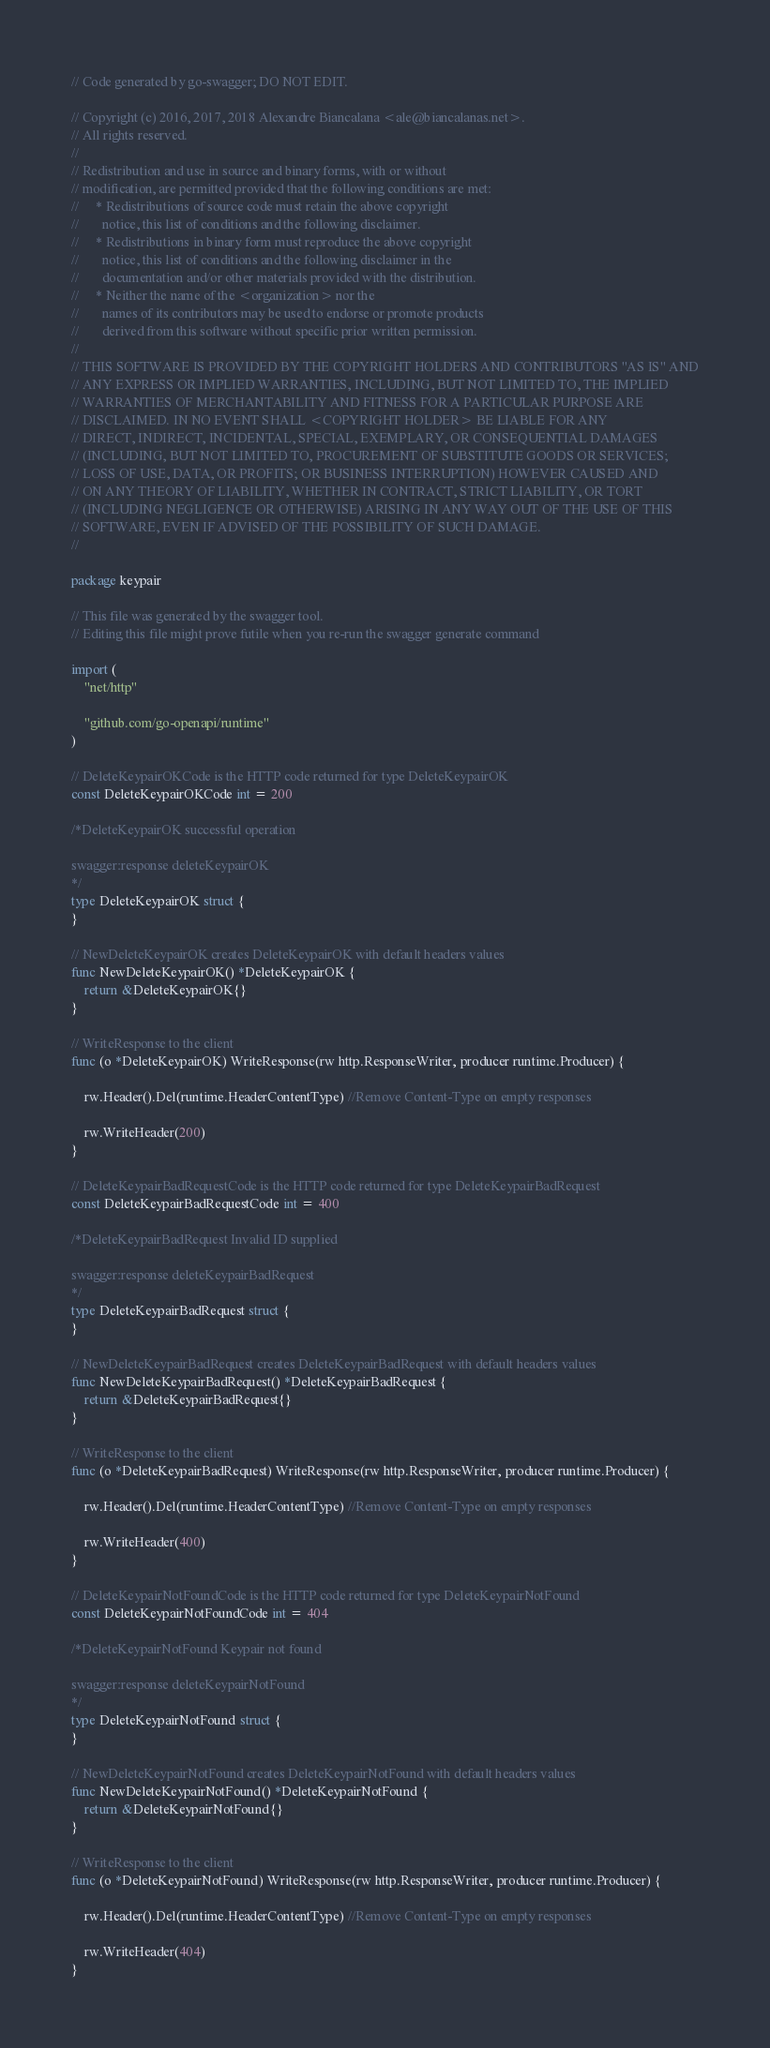Convert code to text. <code><loc_0><loc_0><loc_500><loc_500><_Go_>// Code generated by go-swagger; DO NOT EDIT.

// Copyright (c) 2016, 2017, 2018 Alexandre Biancalana <ale@biancalanas.net>.
// All rights reserved.
//
// Redistribution and use in source and binary forms, with or without
// modification, are permitted provided that the following conditions are met:
//     * Redistributions of source code must retain the above copyright
//       notice, this list of conditions and the following disclaimer.
//     * Redistributions in binary form must reproduce the above copyright
//       notice, this list of conditions and the following disclaimer in the
//       documentation and/or other materials provided with the distribution.
//     * Neither the name of the <organization> nor the
//       names of its contributors may be used to endorse or promote products
//       derived from this software without specific prior written permission.
//
// THIS SOFTWARE IS PROVIDED BY THE COPYRIGHT HOLDERS AND CONTRIBUTORS "AS IS" AND
// ANY EXPRESS OR IMPLIED WARRANTIES, INCLUDING, BUT NOT LIMITED TO, THE IMPLIED
// WARRANTIES OF MERCHANTABILITY AND FITNESS FOR A PARTICULAR PURPOSE ARE
// DISCLAIMED. IN NO EVENT SHALL <COPYRIGHT HOLDER> BE LIABLE FOR ANY
// DIRECT, INDIRECT, INCIDENTAL, SPECIAL, EXEMPLARY, OR CONSEQUENTIAL DAMAGES
// (INCLUDING, BUT NOT LIMITED TO, PROCUREMENT OF SUBSTITUTE GOODS OR SERVICES;
// LOSS OF USE, DATA, OR PROFITS; OR BUSINESS INTERRUPTION) HOWEVER CAUSED AND
// ON ANY THEORY OF LIABILITY, WHETHER IN CONTRACT, STRICT LIABILITY, OR TORT
// (INCLUDING NEGLIGENCE OR OTHERWISE) ARISING IN ANY WAY OUT OF THE USE OF THIS
// SOFTWARE, EVEN IF ADVISED OF THE POSSIBILITY OF SUCH DAMAGE.
//

package keypair

// This file was generated by the swagger tool.
// Editing this file might prove futile when you re-run the swagger generate command

import (
	"net/http"

	"github.com/go-openapi/runtime"
)

// DeleteKeypairOKCode is the HTTP code returned for type DeleteKeypairOK
const DeleteKeypairOKCode int = 200

/*DeleteKeypairOK successful operation

swagger:response deleteKeypairOK
*/
type DeleteKeypairOK struct {
}

// NewDeleteKeypairOK creates DeleteKeypairOK with default headers values
func NewDeleteKeypairOK() *DeleteKeypairOK {
	return &DeleteKeypairOK{}
}

// WriteResponse to the client
func (o *DeleteKeypairOK) WriteResponse(rw http.ResponseWriter, producer runtime.Producer) {

	rw.Header().Del(runtime.HeaderContentType) //Remove Content-Type on empty responses

	rw.WriteHeader(200)
}

// DeleteKeypairBadRequestCode is the HTTP code returned for type DeleteKeypairBadRequest
const DeleteKeypairBadRequestCode int = 400

/*DeleteKeypairBadRequest Invalid ID supplied

swagger:response deleteKeypairBadRequest
*/
type DeleteKeypairBadRequest struct {
}

// NewDeleteKeypairBadRequest creates DeleteKeypairBadRequest with default headers values
func NewDeleteKeypairBadRequest() *DeleteKeypairBadRequest {
	return &DeleteKeypairBadRequest{}
}

// WriteResponse to the client
func (o *DeleteKeypairBadRequest) WriteResponse(rw http.ResponseWriter, producer runtime.Producer) {

	rw.Header().Del(runtime.HeaderContentType) //Remove Content-Type on empty responses

	rw.WriteHeader(400)
}

// DeleteKeypairNotFoundCode is the HTTP code returned for type DeleteKeypairNotFound
const DeleteKeypairNotFoundCode int = 404

/*DeleteKeypairNotFound Keypair not found

swagger:response deleteKeypairNotFound
*/
type DeleteKeypairNotFound struct {
}

// NewDeleteKeypairNotFound creates DeleteKeypairNotFound with default headers values
func NewDeleteKeypairNotFound() *DeleteKeypairNotFound {
	return &DeleteKeypairNotFound{}
}

// WriteResponse to the client
func (o *DeleteKeypairNotFound) WriteResponse(rw http.ResponseWriter, producer runtime.Producer) {

	rw.Header().Del(runtime.HeaderContentType) //Remove Content-Type on empty responses

	rw.WriteHeader(404)
}
</code> 